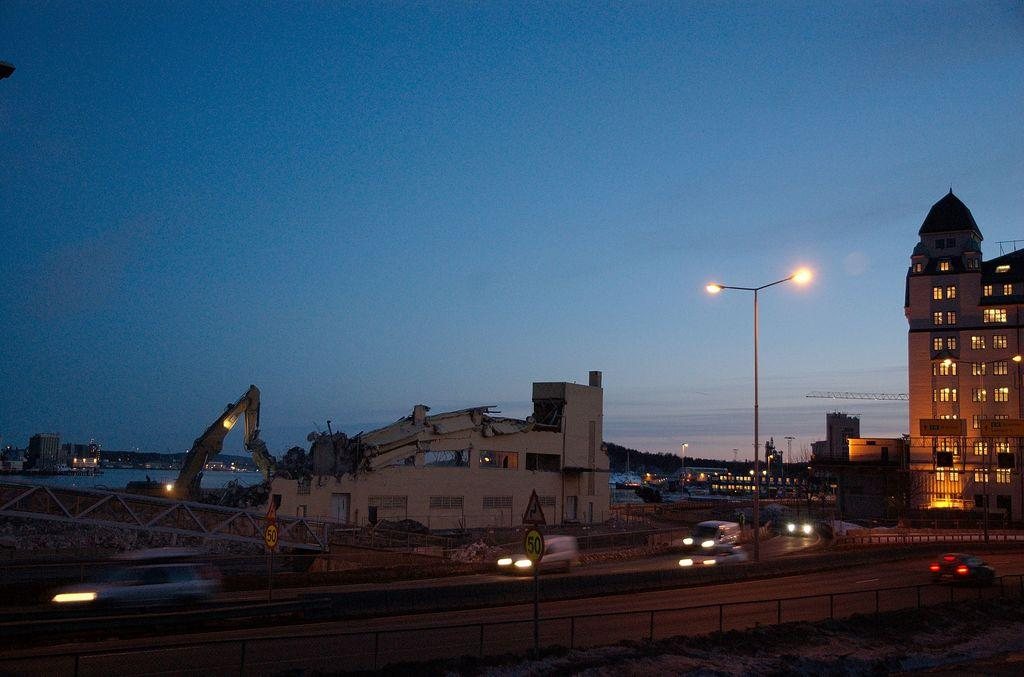What type of structures can be seen in the image? There are buildings in the image. What is the tall, vertical object in the image? There is a light pole in the image. What is moving on the road in the image? There are vehicles on the road in the image. What natural elements are visible in the background of the image? The background of the image includes water and the sky in blue color. Where is the jar located in the image? There is no jar present in the image. What type of attraction can be seen in the image? There is no specific attraction mentioned or visible in the image; it primarily features buildings, a light pole, vehicles, water, and the sky. 